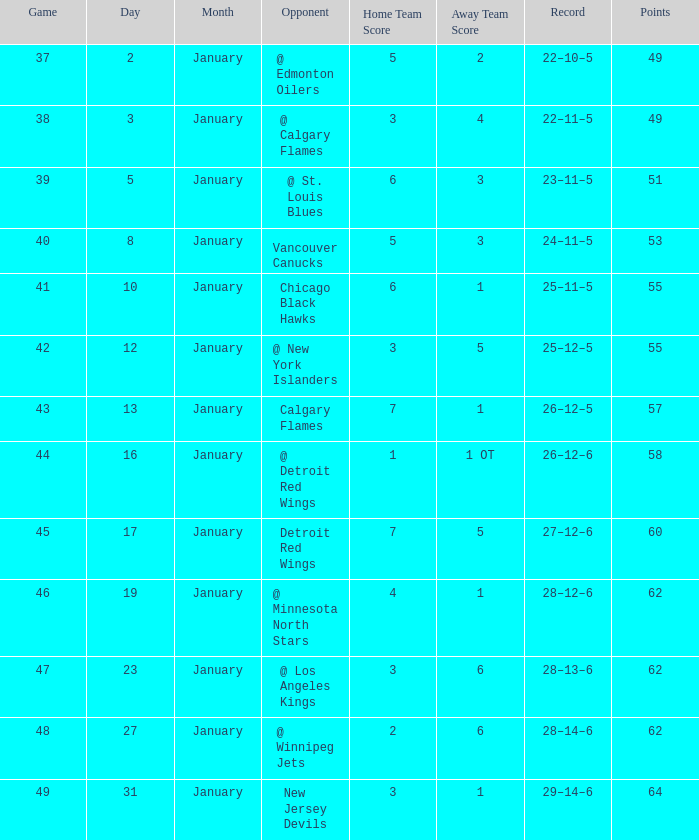How much January has a Record of 26–12–6, and Points smaller than 58? None. 